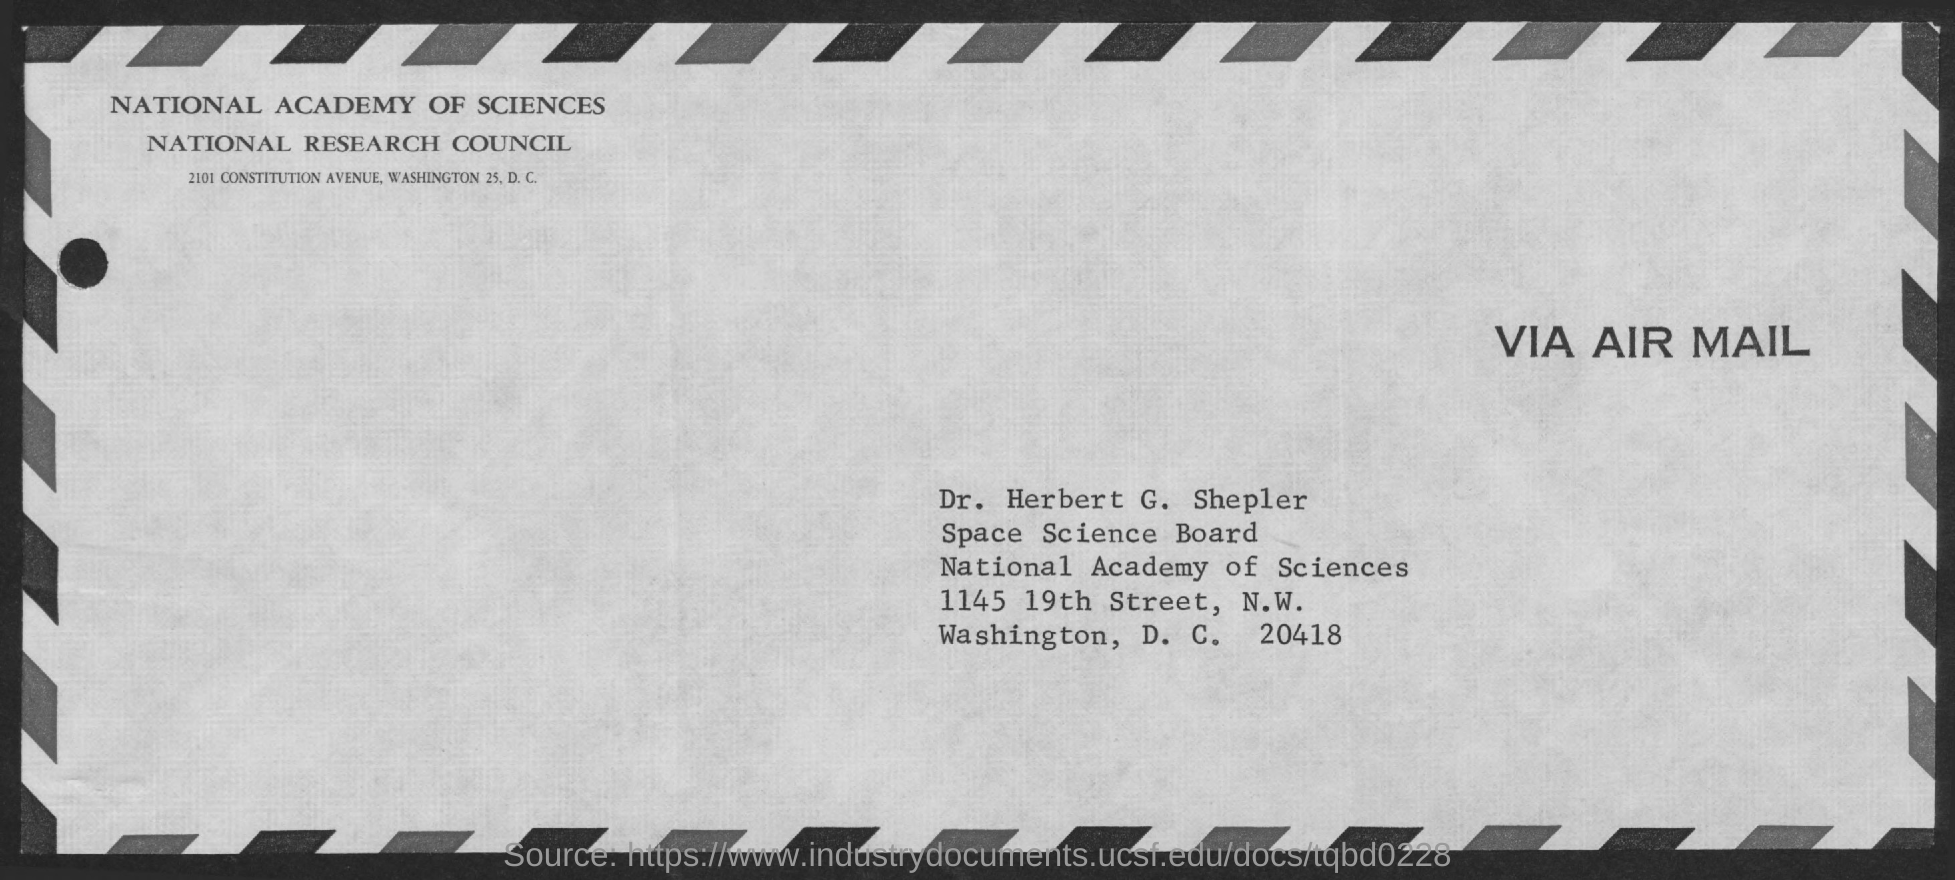To Whom is this Air Mail addressed to?
Your response must be concise. Dr. Herbert G. Shepler. 